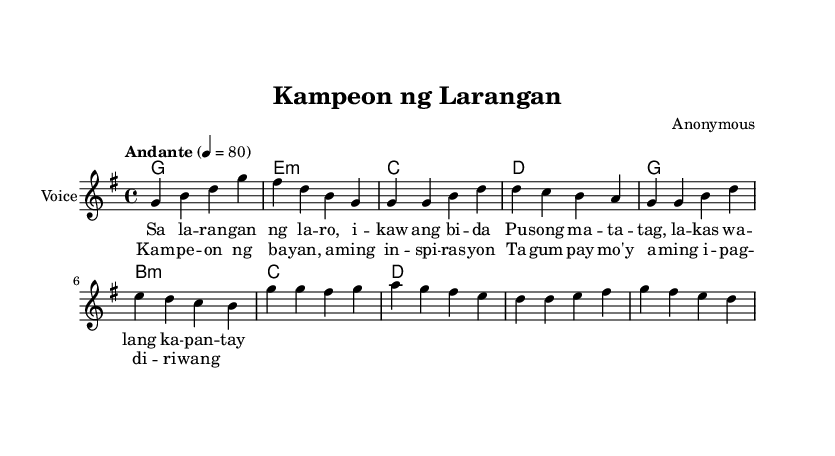What is the key signature of this music? The key signature is specified in the global section of the code where it states "\key g \major". This indicates that there is one sharp in the key of G major.
Answer: G major What is the time signature of this music? The time signature can be found in the global section where it states "\time 4/4". This means there are four beats in a measure and a quarter note gets one beat.
Answer: 4/4 What is the tempo marking in this piece? The tempo indication in the global section is "\tempo 'Andante' 4 = 80". This suggests that the piece should be played at a moderate speed, specifically at 80 beats per minute.
Answer: Andante, 80 What is the main theme expressed in the chorus? The chorus lyrics state "Kampeon ng bayan, aming inspirasyon" which translates to "Champion of the nation, our inspiration". This phrase encapsulates the theme of honoring and celebrating champions in sports.
Answer: Champion of the nation What is the harmonic structure used in the chorus? The chords used in the chorus are indicated in the harmonies section with the progression g, d, e minor, and a minor. Each chord corresponds with the melody and supports the lyrical content of the chorus harmonically.
Answer: g, d, e minor, a minor How does the music change between the verse and chorus? The music maintains the same tempo and key signature but changes in harmony and melodic lines. For instance, the verses use more stepwise motion while the chorus presents a more dynamic and uplifting movement, enhancing the celebratory nature of the lyrics.
Answer: Changes in harmony and melody 